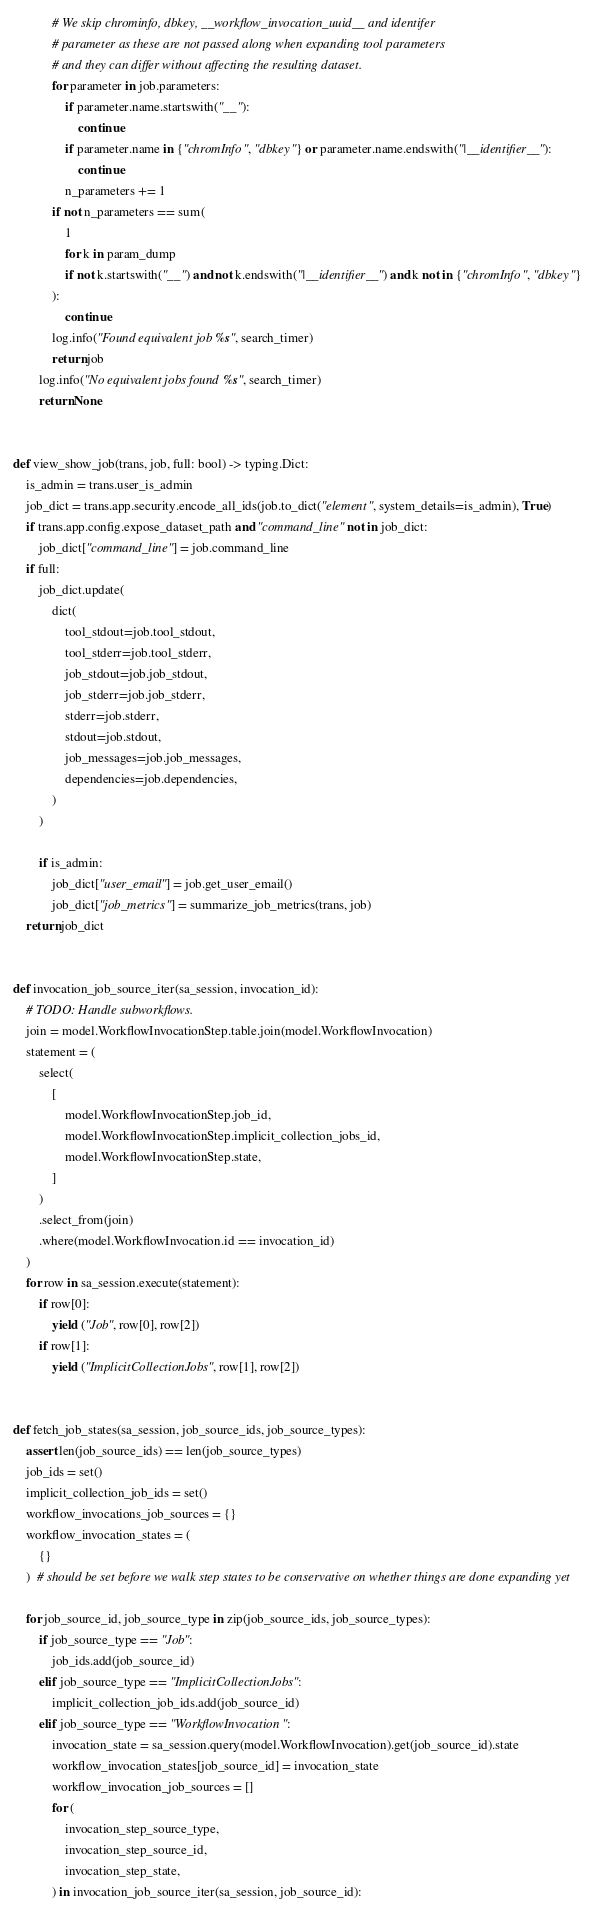<code> <loc_0><loc_0><loc_500><loc_500><_Python_>            # We skip chrominfo, dbkey, __workflow_invocation_uuid__ and identifer
            # parameter as these are not passed along when expanding tool parameters
            # and they can differ without affecting the resulting dataset.
            for parameter in job.parameters:
                if parameter.name.startswith("__"):
                    continue
                if parameter.name in {"chromInfo", "dbkey"} or parameter.name.endswith("|__identifier__"):
                    continue
                n_parameters += 1
            if not n_parameters == sum(
                1
                for k in param_dump
                if not k.startswith("__") and not k.endswith("|__identifier__") and k not in {"chromInfo", "dbkey"}
            ):
                continue
            log.info("Found equivalent job %s", search_timer)
            return job
        log.info("No equivalent jobs found %s", search_timer)
        return None


def view_show_job(trans, job, full: bool) -> typing.Dict:
    is_admin = trans.user_is_admin
    job_dict = trans.app.security.encode_all_ids(job.to_dict("element", system_details=is_admin), True)
    if trans.app.config.expose_dataset_path and "command_line" not in job_dict:
        job_dict["command_line"] = job.command_line
    if full:
        job_dict.update(
            dict(
                tool_stdout=job.tool_stdout,
                tool_stderr=job.tool_stderr,
                job_stdout=job.job_stdout,
                job_stderr=job.job_stderr,
                stderr=job.stderr,
                stdout=job.stdout,
                job_messages=job.job_messages,
                dependencies=job.dependencies,
            )
        )

        if is_admin:
            job_dict["user_email"] = job.get_user_email()
            job_dict["job_metrics"] = summarize_job_metrics(trans, job)
    return job_dict


def invocation_job_source_iter(sa_session, invocation_id):
    # TODO: Handle subworkflows.
    join = model.WorkflowInvocationStep.table.join(model.WorkflowInvocation)
    statement = (
        select(
            [
                model.WorkflowInvocationStep.job_id,
                model.WorkflowInvocationStep.implicit_collection_jobs_id,
                model.WorkflowInvocationStep.state,
            ]
        )
        .select_from(join)
        .where(model.WorkflowInvocation.id == invocation_id)
    )
    for row in sa_session.execute(statement):
        if row[0]:
            yield ("Job", row[0], row[2])
        if row[1]:
            yield ("ImplicitCollectionJobs", row[1], row[2])


def fetch_job_states(sa_session, job_source_ids, job_source_types):
    assert len(job_source_ids) == len(job_source_types)
    job_ids = set()
    implicit_collection_job_ids = set()
    workflow_invocations_job_sources = {}
    workflow_invocation_states = (
        {}
    )  # should be set before we walk step states to be conservative on whether things are done expanding yet

    for job_source_id, job_source_type in zip(job_source_ids, job_source_types):
        if job_source_type == "Job":
            job_ids.add(job_source_id)
        elif job_source_type == "ImplicitCollectionJobs":
            implicit_collection_job_ids.add(job_source_id)
        elif job_source_type == "WorkflowInvocation":
            invocation_state = sa_session.query(model.WorkflowInvocation).get(job_source_id).state
            workflow_invocation_states[job_source_id] = invocation_state
            workflow_invocation_job_sources = []
            for (
                invocation_step_source_type,
                invocation_step_source_id,
                invocation_step_state,
            ) in invocation_job_source_iter(sa_session, job_source_id):</code> 